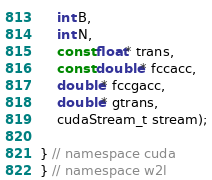Convert code to text. <code><loc_0><loc_0><loc_500><loc_500><_Cuda_>    int B,
    int N,
    const float* trans,
    const double* fccacc,
    double* fccgacc,
    double* gtrans,
    cudaStream_t stream);

} // namespace cuda
} // namespace w2l
</code> 